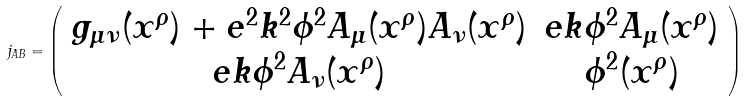<formula> <loc_0><loc_0><loc_500><loc_500>j _ { A B } = \left ( \begin{array} { c c } g _ { \mu \nu } ( x ^ { \rho } ) + e ^ { 2 } k ^ { 2 } \phi ^ { 2 } A _ { \mu } ( x ^ { \rho } ) A _ { \nu } ( x ^ { \rho } ) & e k \phi ^ { 2 } A _ { \mu } ( x ^ { \rho } ) \\ e k \phi ^ { 2 } A _ { \nu } ( x ^ { \rho } ) & \phi ^ { 2 } ( x ^ { \rho } ) \end{array} \right )</formula> 